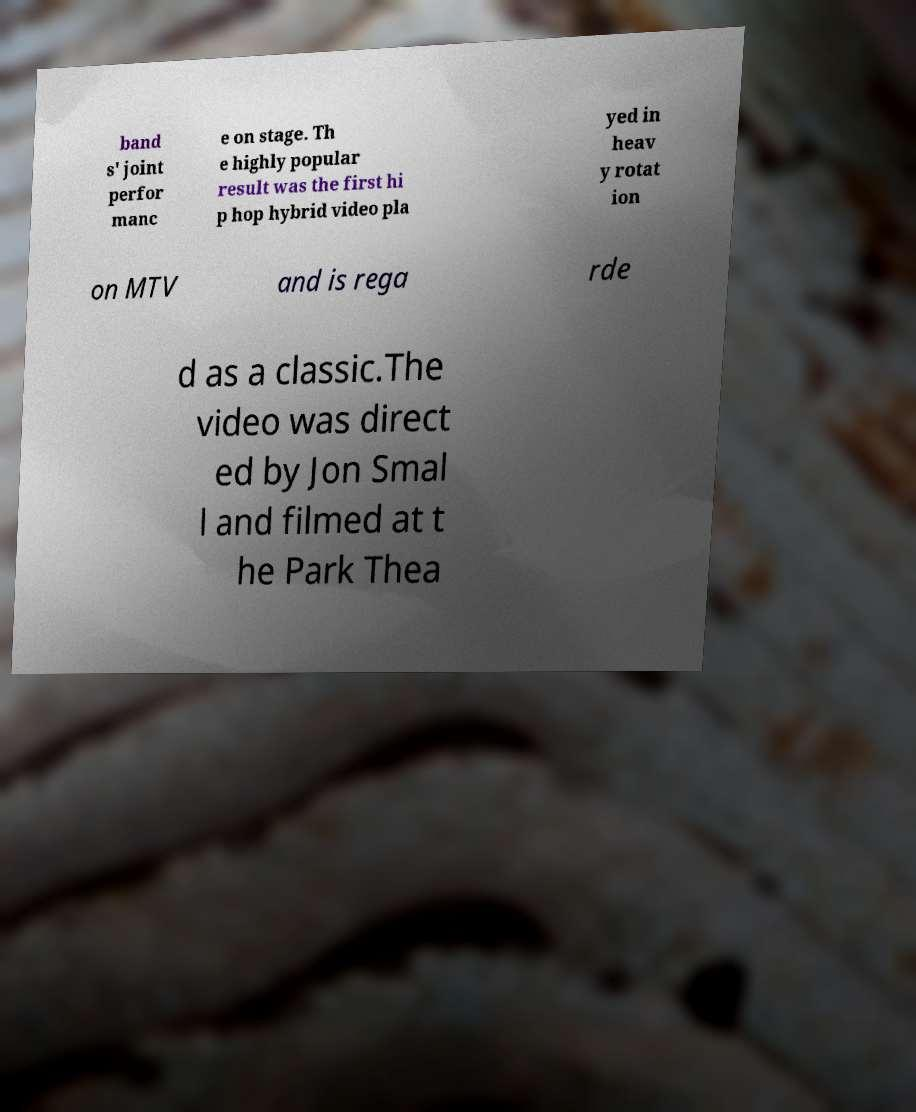There's text embedded in this image that I need extracted. Can you transcribe it verbatim? band s' joint perfor manc e on stage. Th e highly popular result was the first hi p hop hybrid video pla yed in heav y rotat ion on MTV and is rega rde d as a classic.The video was direct ed by Jon Smal l and filmed at t he Park Thea 